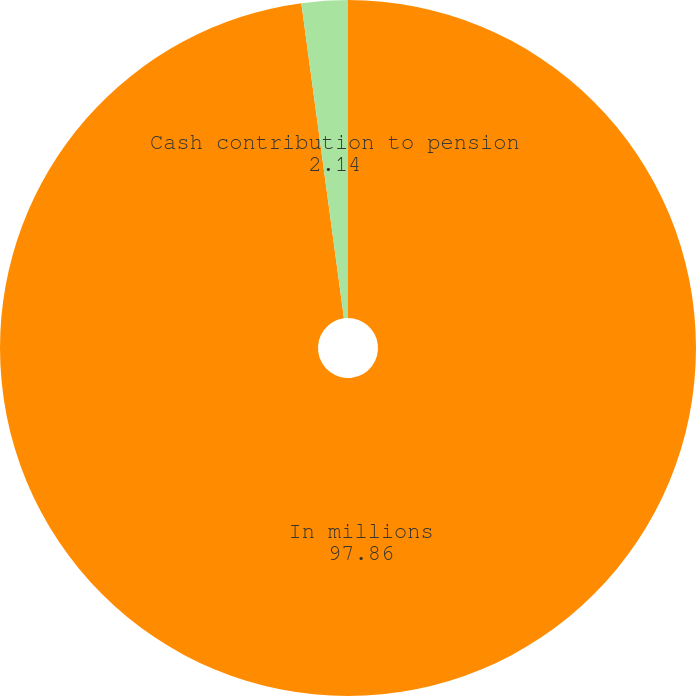Convert chart to OTSL. <chart><loc_0><loc_0><loc_500><loc_500><pie_chart><fcel>In millions<fcel>Cash contribution to pension<nl><fcel>97.86%<fcel>2.14%<nl></chart> 